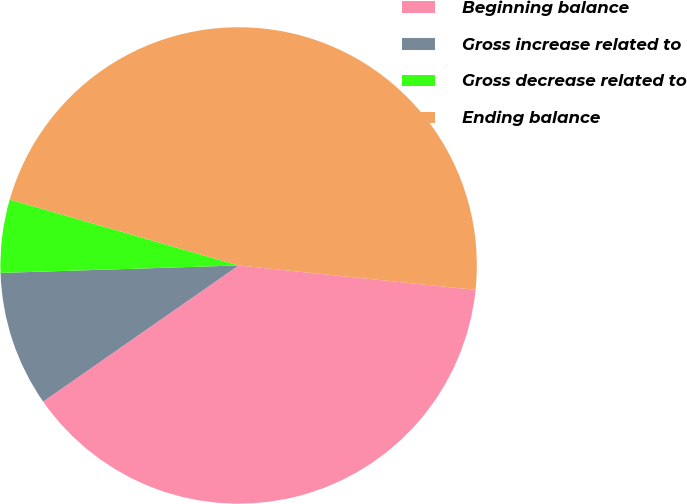Convert chart. <chart><loc_0><loc_0><loc_500><loc_500><pie_chart><fcel>Beginning balance<fcel>Gross increase related to<fcel>Gross decrease related to<fcel>Ending balance<nl><fcel>38.68%<fcel>9.18%<fcel>4.96%<fcel>47.17%<nl></chart> 